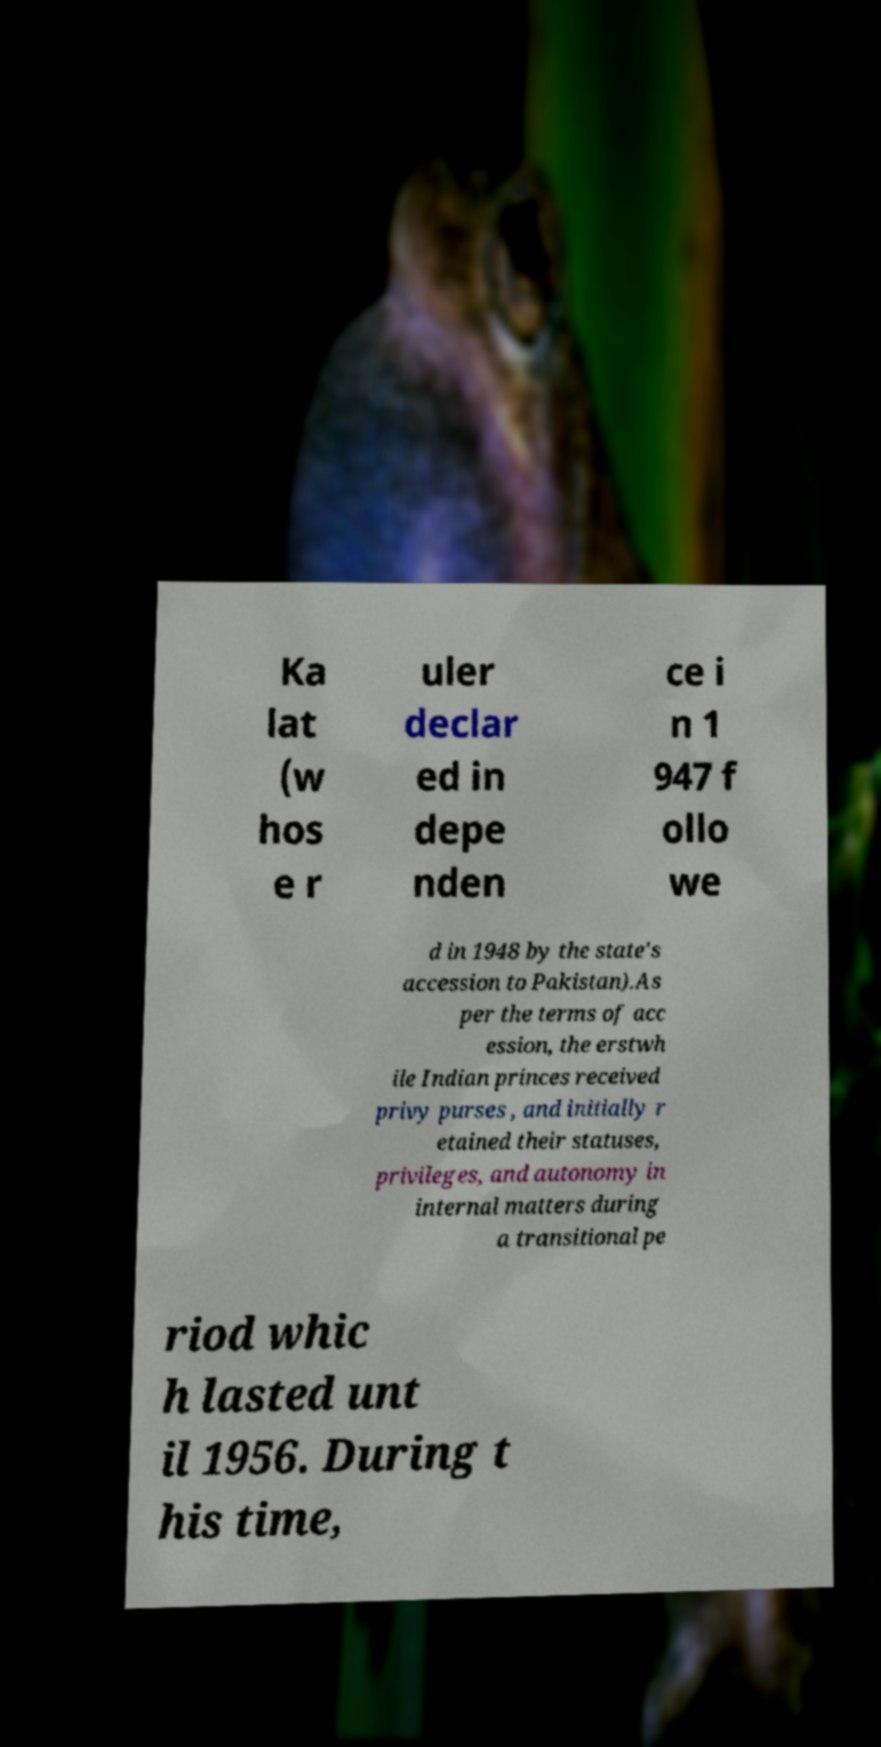I need the written content from this picture converted into text. Can you do that? Ka lat (w hos e r uler declar ed in depe nden ce i n 1 947 f ollo we d in 1948 by the state's accession to Pakistan).As per the terms of acc ession, the erstwh ile Indian princes received privy purses , and initially r etained their statuses, privileges, and autonomy in internal matters during a transitional pe riod whic h lasted unt il 1956. During t his time, 